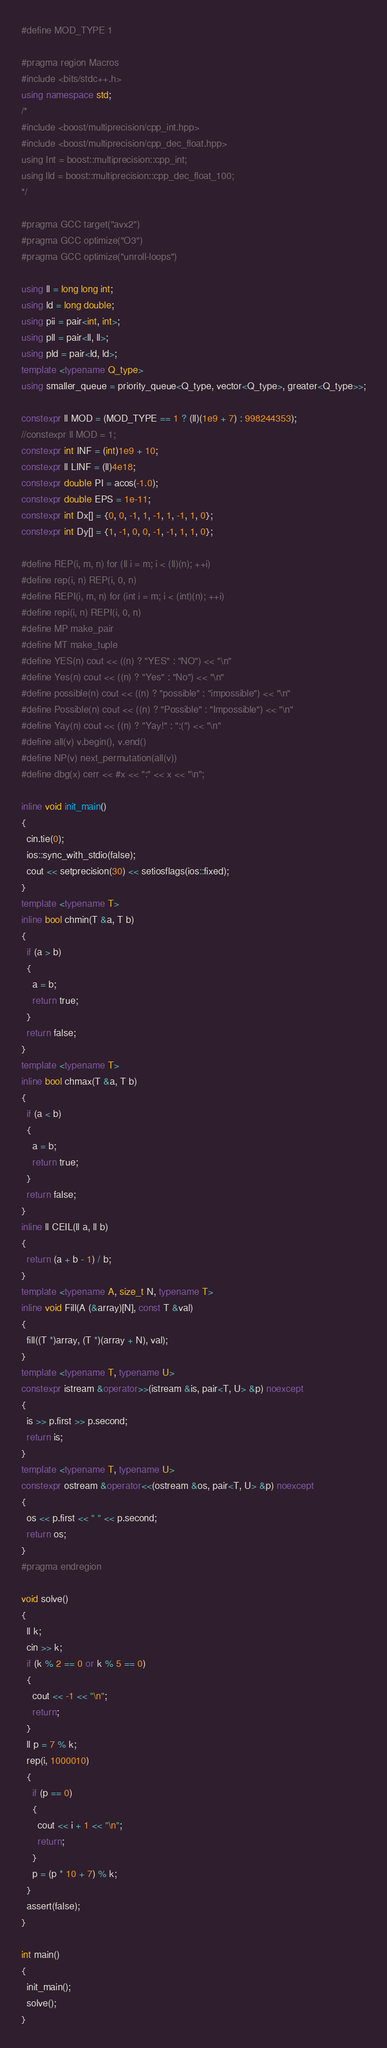Convert code to text. <code><loc_0><loc_0><loc_500><loc_500><_C++_>#define MOD_TYPE 1

#pragma region Macros
#include <bits/stdc++.h>
using namespace std;
/*
#include <boost/multiprecision/cpp_int.hpp>
#include <boost/multiprecision/cpp_dec_float.hpp>
using Int = boost::multiprecision::cpp_int;
using lld = boost::multiprecision::cpp_dec_float_100;
*/

#pragma GCC target("avx2")
#pragma GCC optimize("O3")
#pragma GCC optimize("unroll-loops")

using ll = long long int;
using ld = long double;
using pii = pair<int, int>;
using pll = pair<ll, ll>;
using pld = pair<ld, ld>;
template <typename Q_type>
using smaller_queue = priority_queue<Q_type, vector<Q_type>, greater<Q_type>>;

constexpr ll MOD = (MOD_TYPE == 1 ? (ll)(1e9 + 7) : 998244353);
//constexpr ll MOD = 1;
constexpr int INF = (int)1e9 + 10;
constexpr ll LINF = (ll)4e18;
constexpr double PI = acos(-1.0);
constexpr double EPS = 1e-11;
constexpr int Dx[] = {0, 0, -1, 1, -1, 1, -1, 1, 0};
constexpr int Dy[] = {1, -1, 0, 0, -1, -1, 1, 1, 0};

#define REP(i, m, n) for (ll i = m; i < (ll)(n); ++i)
#define rep(i, n) REP(i, 0, n)
#define REPI(i, m, n) for (int i = m; i < (int)(n); ++i)
#define repi(i, n) REPI(i, 0, n)
#define MP make_pair
#define MT make_tuple
#define YES(n) cout << ((n) ? "YES" : "NO") << "\n"
#define Yes(n) cout << ((n) ? "Yes" : "No") << "\n"
#define possible(n) cout << ((n) ? "possible" : "impossible") << "\n"
#define Possible(n) cout << ((n) ? "Possible" : "Impossible") << "\n"
#define Yay(n) cout << ((n) ? "Yay!" : ":(") << "\n"
#define all(v) v.begin(), v.end()
#define NP(v) next_permutation(all(v))
#define dbg(x) cerr << #x << ":" << x << "\n";

inline void init_main()
{
  cin.tie(0);
  ios::sync_with_stdio(false);
  cout << setprecision(30) << setiosflags(ios::fixed);
}
template <typename T>
inline bool chmin(T &a, T b)
{
  if (a > b)
  {
    a = b;
    return true;
  }
  return false;
}
template <typename T>
inline bool chmax(T &a, T b)
{
  if (a < b)
  {
    a = b;
    return true;
  }
  return false;
}
inline ll CEIL(ll a, ll b)
{
  return (a + b - 1) / b;
}
template <typename A, size_t N, typename T>
inline void Fill(A (&array)[N], const T &val)
{
  fill((T *)array, (T *)(array + N), val);
}
template <typename T, typename U>
constexpr istream &operator>>(istream &is, pair<T, U> &p) noexcept
{
  is >> p.first >> p.second;
  return is;
}
template <typename T, typename U>
constexpr ostream &operator<<(ostream &os, pair<T, U> &p) noexcept
{
  os << p.first << " " << p.second;
  return os;
}
#pragma endregion

void solve()
{
  ll k;
  cin >> k;
  if (k % 2 == 0 or k % 5 == 0)
  {
    cout << -1 << "\n";
    return;
  }
  ll p = 7 % k;
  rep(i, 1000010)
  {
    if (p == 0)
    {
      cout << i + 1 << "\n";
      return;
    }
    p = (p * 10 + 7) % k;
  }
  assert(false);
}

int main()
{
  init_main();
  solve();
}
</code> 